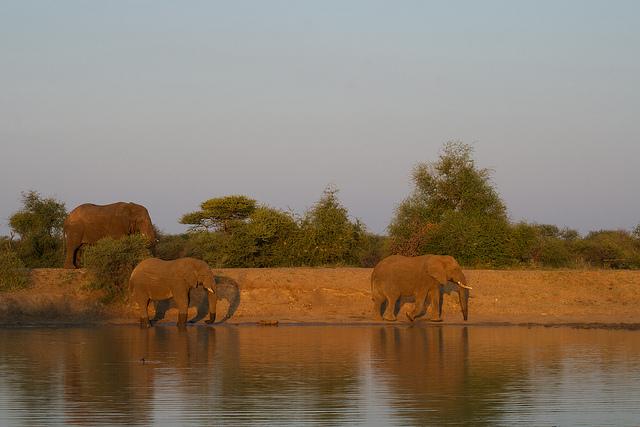Are either animal wet?
Short answer required. Yes. What's behind the wall of rock?
Answer briefly. Trees. How many animals in this scene?
Give a very brief answer. 3. Is the elephant real?
Give a very brief answer. Yes. What number of elephants are standing in the river?
Quick response, please. 2. Is it raining?
Quick response, please. No. Are the two elephants fighting?
Concise answer only. No. 